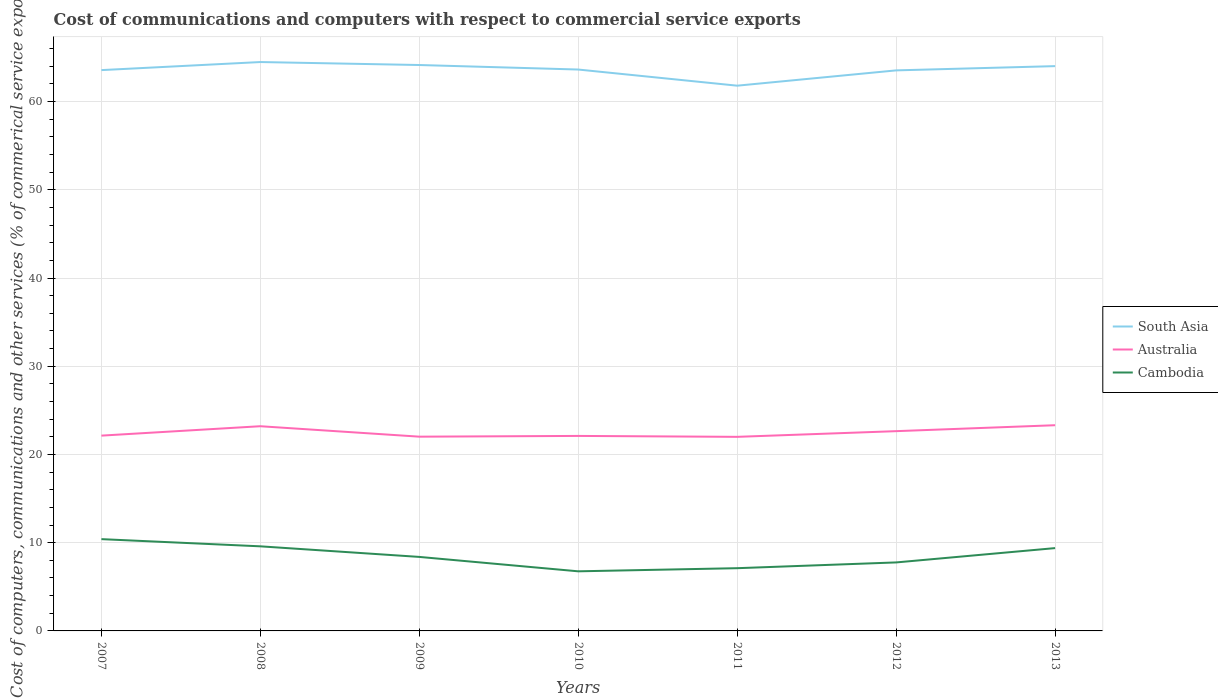How many different coloured lines are there?
Offer a very short reply. 3. Does the line corresponding to Australia intersect with the line corresponding to South Asia?
Offer a terse response. No. Is the number of lines equal to the number of legend labels?
Offer a very short reply. Yes. Across all years, what is the maximum cost of communications and computers in Australia?
Provide a short and direct response. 22. What is the total cost of communications and computers in South Asia in the graph?
Offer a very short reply. 0.95. What is the difference between the highest and the second highest cost of communications and computers in South Asia?
Give a very brief answer. 2.68. What is the difference between the highest and the lowest cost of communications and computers in Australia?
Ensure brevity in your answer.  3. Is the cost of communications and computers in Cambodia strictly greater than the cost of communications and computers in Australia over the years?
Your response must be concise. Yes. How many years are there in the graph?
Provide a succinct answer. 7. Are the values on the major ticks of Y-axis written in scientific E-notation?
Provide a short and direct response. No. How many legend labels are there?
Provide a succinct answer. 3. What is the title of the graph?
Make the answer very short. Cost of communications and computers with respect to commercial service exports. What is the label or title of the Y-axis?
Provide a succinct answer. Cost of computers, communications and other services (% of commerical service exports). What is the Cost of computers, communications and other services (% of commerical service exports) of South Asia in 2007?
Your answer should be very brief. 63.57. What is the Cost of computers, communications and other services (% of commerical service exports) of Australia in 2007?
Make the answer very short. 22.14. What is the Cost of computers, communications and other services (% of commerical service exports) in Cambodia in 2007?
Ensure brevity in your answer.  10.4. What is the Cost of computers, communications and other services (% of commerical service exports) in South Asia in 2008?
Keep it short and to the point. 64.49. What is the Cost of computers, communications and other services (% of commerical service exports) in Australia in 2008?
Your response must be concise. 23.2. What is the Cost of computers, communications and other services (% of commerical service exports) in Cambodia in 2008?
Your answer should be very brief. 9.59. What is the Cost of computers, communications and other services (% of commerical service exports) in South Asia in 2009?
Your answer should be very brief. 64.15. What is the Cost of computers, communications and other services (% of commerical service exports) of Australia in 2009?
Ensure brevity in your answer.  22.02. What is the Cost of computers, communications and other services (% of commerical service exports) of Cambodia in 2009?
Your response must be concise. 8.39. What is the Cost of computers, communications and other services (% of commerical service exports) in South Asia in 2010?
Provide a short and direct response. 63.64. What is the Cost of computers, communications and other services (% of commerical service exports) of Australia in 2010?
Provide a short and direct response. 22.1. What is the Cost of computers, communications and other services (% of commerical service exports) of Cambodia in 2010?
Your answer should be very brief. 6.76. What is the Cost of computers, communications and other services (% of commerical service exports) of South Asia in 2011?
Your response must be concise. 61.81. What is the Cost of computers, communications and other services (% of commerical service exports) of Australia in 2011?
Offer a very short reply. 22. What is the Cost of computers, communications and other services (% of commerical service exports) in Cambodia in 2011?
Make the answer very short. 7.11. What is the Cost of computers, communications and other services (% of commerical service exports) in South Asia in 2012?
Your answer should be very brief. 63.54. What is the Cost of computers, communications and other services (% of commerical service exports) in Australia in 2012?
Offer a very short reply. 22.64. What is the Cost of computers, communications and other services (% of commerical service exports) of Cambodia in 2012?
Your answer should be compact. 7.76. What is the Cost of computers, communications and other services (% of commerical service exports) in South Asia in 2013?
Provide a succinct answer. 64.02. What is the Cost of computers, communications and other services (% of commerical service exports) in Australia in 2013?
Provide a short and direct response. 23.32. What is the Cost of computers, communications and other services (% of commerical service exports) of Cambodia in 2013?
Your answer should be compact. 9.39. Across all years, what is the maximum Cost of computers, communications and other services (% of commerical service exports) in South Asia?
Offer a very short reply. 64.49. Across all years, what is the maximum Cost of computers, communications and other services (% of commerical service exports) of Australia?
Your response must be concise. 23.32. Across all years, what is the maximum Cost of computers, communications and other services (% of commerical service exports) in Cambodia?
Keep it short and to the point. 10.4. Across all years, what is the minimum Cost of computers, communications and other services (% of commerical service exports) of South Asia?
Provide a succinct answer. 61.81. Across all years, what is the minimum Cost of computers, communications and other services (% of commerical service exports) in Australia?
Keep it short and to the point. 22. Across all years, what is the minimum Cost of computers, communications and other services (% of commerical service exports) of Cambodia?
Your response must be concise. 6.76. What is the total Cost of computers, communications and other services (% of commerical service exports) in South Asia in the graph?
Offer a very short reply. 445.21. What is the total Cost of computers, communications and other services (% of commerical service exports) in Australia in the graph?
Give a very brief answer. 157.42. What is the total Cost of computers, communications and other services (% of commerical service exports) in Cambodia in the graph?
Keep it short and to the point. 59.4. What is the difference between the Cost of computers, communications and other services (% of commerical service exports) of South Asia in 2007 and that in 2008?
Your answer should be very brief. -0.92. What is the difference between the Cost of computers, communications and other services (% of commerical service exports) in Australia in 2007 and that in 2008?
Your response must be concise. -1.07. What is the difference between the Cost of computers, communications and other services (% of commerical service exports) of Cambodia in 2007 and that in 2008?
Your answer should be compact. 0.81. What is the difference between the Cost of computers, communications and other services (% of commerical service exports) in South Asia in 2007 and that in 2009?
Ensure brevity in your answer.  -0.58. What is the difference between the Cost of computers, communications and other services (% of commerical service exports) in Australia in 2007 and that in 2009?
Ensure brevity in your answer.  0.12. What is the difference between the Cost of computers, communications and other services (% of commerical service exports) of Cambodia in 2007 and that in 2009?
Your answer should be compact. 2.01. What is the difference between the Cost of computers, communications and other services (% of commerical service exports) in South Asia in 2007 and that in 2010?
Keep it short and to the point. -0.07. What is the difference between the Cost of computers, communications and other services (% of commerical service exports) in Australia in 2007 and that in 2010?
Your answer should be very brief. 0.03. What is the difference between the Cost of computers, communications and other services (% of commerical service exports) of Cambodia in 2007 and that in 2010?
Your answer should be very brief. 3.65. What is the difference between the Cost of computers, communications and other services (% of commerical service exports) of South Asia in 2007 and that in 2011?
Ensure brevity in your answer.  1.76. What is the difference between the Cost of computers, communications and other services (% of commerical service exports) of Australia in 2007 and that in 2011?
Give a very brief answer. 0.14. What is the difference between the Cost of computers, communications and other services (% of commerical service exports) in Cambodia in 2007 and that in 2011?
Give a very brief answer. 3.29. What is the difference between the Cost of computers, communications and other services (% of commerical service exports) in South Asia in 2007 and that in 2012?
Your answer should be very brief. 0.03. What is the difference between the Cost of computers, communications and other services (% of commerical service exports) in Australia in 2007 and that in 2012?
Give a very brief answer. -0.51. What is the difference between the Cost of computers, communications and other services (% of commerical service exports) in Cambodia in 2007 and that in 2012?
Keep it short and to the point. 2.64. What is the difference between the Cost of computers, communications and other services (% of commerical service exports) of South Asia in 2007 and that in 2013?
Provide a succinct answer. -0.45. What is the difference between the Cost of computers, communications and other services (% of commerical service exports) in Australia in 2007 and that in 2013?
Your answer should be compact. -1.18. What is the difference between the Cost of computers, communications and other services (% of commerical service exports) in Cambodia in 2007 and that in 2013?
Keep it short and to the point. 1.01. What is the difference between the Cost of computers, communications and other services (% of commerical service exports) of South Asia in 2008 and that in 2009?
Make the answer very short. 0.34. What is the difference between the Cost of computers, communications and other services (% of commerical service exports) of Australia in 2008 and that in 2009?
Your answer should be very brief. 1.18. What is the difference between the Cost of computers, communications and other services (% of commerical service exports) of Cambodia in 2008 and that in 2009?
Offer a very short reply. 1.2. What is the difference between the Cost of computers, communications and other services (% of commerical service exports) of South Asia in 2008 and that in 2010?
Provide a short and direct response. 0.85. What is the difference between the Cost of computers, communications and other services (% of commerical service exports) in Australia in 2008 and that in 2010?
Offer a terse response. 1.1. What is the difference between the Cost of computers, communications and other services (% of commerical service exports) in Cambodia in 2008 and that in 2010?
Provide a succinct answer. 2.83. What is the difference between the Cost of computers, communications and other services (% of commerical service exports) in South Asia in 2008 and that in 2011?
Ensure brevity in your answer.  2.68. What is the difference between the Cost of computers, communications and other services (% of commerical service exports) in Australia in 2008 and that in 2011?
Offer a terse response. 1.2. What is the difference between the Cost of computers, communications and other services (% of commerical service exports) in Cambodia in 2008 and that in 2011?
Provide a succinct answer. 2.48. What is the difference between the Cost of computers, communications and other services (% of commerical service exports) of South Asia in 2008 and that in 2012?
Give a very brief answer. 0.95. What is the difference between the Cost of computers, communications and other services (% of commerical service exports) of Australia in 2008 and that in 2012?
Your answer should be compact. 0.56. What is the difference between the Cost of computers, communications and other services (% of commerical service exports) in Cambodia in 2008 and that in 2012?
Provide a succinct answer. 1.83. What is the difference between the Cost of computers, communications and other services (% of commerical service exports) of South Asia in 2008 and that in 2013?
Make the answer very short. 0.46. What is the difference between the Cost of computers, communications and other services (% of commerical service exports) of Australia in 2008 and that in 2013?
Offer a very short reply. -0.11. What is the difference between the Cost of computers, communications and other services (% of commerical service exports) in Cambodia in 2008 and that in 2013?
Keep it short and to the point. 0.2. What is the difference between the Cost of computers, communications and other services (% of commerical service exports) in South Asia in 2009 and that in 2010?
Provide a short and direct response. 0.51. What is the difference between the Cost of computers, communications and other services (% of commerical service exports) in Australia in 2009 and that in 2010?
Ensure brevity in your answer.  -0.08. What is the difference between the Cost of computers, communications and other services (% of commerical service exports) of Cambodia in 2009 and that in 2010?
Make the answer very short. 1.63. What is the difference between the Cost of computers, communications and other services (% of commerical service exports) of South Asia in 2009 and that in 2011?
Give a very brief answer. 2.34. What is the difference between the Cost of computers, communications and other services (% of commerical service exports) in Australia in 2009 and that in 2011?
Your response must be concise. 0.02. What is the difference between the Cost of computers, communications and other services (% of commerical service exports) in Cambodia in 2009 and that in 2011?
Offer a very short reply. 1.28. What is the difference between the Cost of computers, communications and other services (% of commerical service exports) of South Asia in 2009 and that in 2012?
Provide a succinct answer. 0.61. What is the difference between the Cost of computers, communications and other services (% of commerical service exports) of Australia in 2009 and that in 2012?
Offer a terse response. -0.62. What is the difference between the Cost of computers, communications and other services (% of commerical service exports) of Cambodia in 2009 and that in 2012?
Your answer should be compact. 0.62. What is the difference between the Cost of computers, communications and other services (% of commerical service exports) in South Asia in 2009 and that in 2013?
Make the answer very short. 0.13. What is the difference between the Cost of computers, communications and other services (% of commerical service exports) in Australia in 2009 and that in 2013?
Keep it short and to the point. -1.3. What is the difference between the Cost of computers, communications and other services (% of commerical service exports) in Cambodia in 2009 and that in 2013?
Give a very brief answer. -1. What is the difference between the Cost of computers, communications and other services (% of commerical service exports) in South Asia in 2010 and that in 2011?
Offer a very short reply. 1.83. What is the difference between the Cost of computers, communications and other services (% of commerical service exports) of Australia in 2010 and that in 2011?
Your answer should be compact. 0.1. What is the difference between the Cost of computers, communications and other services (% of commerical service exports) in Cambodia in 2010 and that in 2011?
Your answer should be compact. -0.35. What is the difference between the Cost of computers, communications and other services (% of commerical service exports) of South Asia in 2010 and that in 2012?
Your answer should be compact. 0.1. What is the difference between the Cost of computers, communications and other services (% of commerical service exports) of Australia in 2010 and that in 2012?
Your response must be concise. -0.54. What is the difference between the Cost of computers, communications and other services (% of commerical service exports) of Cambodia in 2010 and that in 2012?
Provide a succinct answer. -1.01. What is the difference between the Cost of computers, communications and other services (% of commerical service exports) in South Asia in 2010 and that in 2013?
Give a very brief answer. -0.39. What is the difference between the Cost of computers, communications and other services (% of commerical service exports) in Australia in 2010 and that in 2013?
Your answer should be compact. -1.21. What is the difference between the Cost of computers, communications and other services (% of commerical service exports) of Cambodia in 2010 and that in 2013?
Your response must be concise. -2.63. What is the difference between the Cost of computers, communications and other services (% of commerical service exports) of South Asia in 2011 and that in 2012?
Offer a terse response. -1.73. What is the difference between the Cost of computers, communications and other services (% of commerical service exports) in Australia in 2011 and that in 2012?
Make the answer very short. -0.64. What is the difference between the Cost of computers, communications and other services (% of commerical service exports) in Cambodia in 2011 and that in 2012?
Keep it short and to the point. -0.65. What is the difference between the Cost of computers, communications and other services (% of commerical service exports) in South Asia in 2011 and that in 2013?
Your answer should be compact. -2.22. What is the difference between the Cost of computers, communications and other services (% of commerical service exports) of Australia in 2011 and that in 2013?
Offer a very short reply. -1.32. What is the difference between the Cost of computers, communications and other services (% of commerical service exports) in Cambodia in 2011 and that in 2013?
Your response must be concise. -2.28. What is the difference between the Cost of computers, communications and other services (% of commerical service exports) in South Asia in 2012 and that in 2013?
Your response must be concise. -0.48. What is the difference between the Cost of computers, communications and other services (% of commerical service exports) in Australia in 2012 and that in 2013?
Your response must be concise. -0.67. What is the difference between the Cost of computers, communications and other services (% of commerical service exports) in Cambodia in 2012 and that in 2013?
Provide a succinct answer. -1.62. What is the difference between the Cost of computers, communications and other services (% of commerical service exports) in South Asia in 2007 and the Cost of computers, communications and other services (% of commerical service exports) in Australia in 2008?
Provide a short and direct response. 40.37. What is the difference between the Cost of computers, communications and other services (% of commerical service exports) of South Asia in 2007 and the Cost of computers, communications and other services (% of commerical service exports) of Cambodia in 2008?
Offer a very short reply. 53.98. What is the difference between the Cost of computers, communications and other services (% of commerical service exports) in Australia in 2007 and the Cost of computers, communications and other services (% of commerical service exports) in Cambodia in 2008?
Keep it short and to the point. 12.55. What is the difference between the Cost of computers, communications and other services (% of commerical service exports) of South Asia in 2007 and the Cost of computers, communications and other services (% of commerical service exports) of Australia in 2009?
Ensure brevity in your answer.  41.55. What is the difference between the Cost of computers, communications and other services (% of commerical service exports) of South Asia in 2007 and the Cost of computers, communications and other services (% of commerical service exports) of Cambodia in 2009?
Offer a terse response. 55.18. What is the difference between the Cost of computers, communications and other services (% of commerical service exports) of Australia in 2007 and the Cost of computers, communications and other services (% of commerical service exports) of Cambodia in 2009?
Provide a short and direct response. 13.75. What is the difference between the Cost of computers, communications and other services (% of commerical service exports) in South Asia in 2007 and the Cost of computers, communications and other services (% of commerical service exports) in Australia in 2010?
Provide a succinct answer. 41.47. What is the difference between the Cost of computers, communications and other services (% of commerical service exports) of South Asia in 2007 and the Cost of computers, communications and other services (% of commerical service exports) of Cambodia in 2010?
Your answer should be compact. 56.81. What is the difference between the Cost of computers, communications and other services (% of commerical service exports) in Australia in 2007 and the Cost of computers, communications and other services (% of commerical service exports) in Cambodia in 2010?
Your answer should be very brief. 15.38. What is the difference between the Cost of computers, communications and other services (% of commerical service exports) of South Asia in 2007 and the Cost of computers, communications and other services (% of commerical service exports) of Australia in 2011?
Your answer should be compact. 41.57. What is the difference between the Cost of computers, communications and other services (% of commerical service exports) in South Asia in 2007 and the Cost of computers, communications and other services (% of commerical service exports) in Cambodia in 2011?
Give a very brief answer. 56.46. What is the difference between the Cost of computers, communications and other services (% of commerical service exports) of Australia in 2007 and the Cost of computers, communications and other services (% of commerical service exports) of Cambodia in 2011?
Keep it short and to the point. 15.03. What is the difference between the Cost of computers, communications and other services (% of commerical service exports) of South Asia in 2007 and the Cost of computers, communications and other services (% of commerical service exports) of Australia in 2012?
Give a very brief answer. 40.93. What is the difference between the Cost of computers, communications and other services (% of commerical service exports) of South Asia in 2007 and the Cost of computers, communications and other services (% of commerical service exports) of Cambodia in 2012?
Provide a succinct answer. 55.81. What is the difference between the Cost of computers, communications and other services (% of commerical service exports) in Australia in 2007 and the Cost of computers, communications and other services (% of commerical service exports) in Cambodia in 2012?
Offer a terse response. 14.37. What is the difference between the Cost of computers, communications and other services (% of commerical service exports) in South Asia in 2007 and the Cost of computers, communications and other services (% of commerical service exports) in Australia in 2013?
Make the answer very short. 40.25. What is the difference between the Cost of computers, communications and other services (% of commerical service exports) in South Asia in 2007 and the Cost of computers, communications and other services (% of commerical service exports) in Cambodia in 2013?
Ensure brevity in your answer.  54.18. What is the difference between the Cost of computers, communications and other services (% of commerical service exports) of Australia in 2007 and the Cost of computers, communications and other services (% of commerical service exports) of Cambodia in 2013?
Provide a short and direct response. 12.75. What is the difference between the Cost of computers, communications and other services (% of commerical service exports) of South Asia in 2008 and the Cost of computers, communications and other services (% of commerical service exports) of Australia in 2009?
Ensure brevity in your answer.  42.47. What is the difference between the Cost of computers, communications and other services (% of commerical service exports) of South Asia in 2008 and the Cost of computers, communications and other services (% of commerical service exports) of Cambodia in 2009?
Offer a terse response. 56.1. What is the difference between the Cost of computers, communications and other services (% of commerical service exports) of Australia in 2008 and the Cost of computers, communications and other services (% of commerical service exports) of Cambodia in 2009?
Your answer should be compact. 14.81. What is the difference between the Cost of computers, communications and other services (% of commerical service exports) in South Asia in 2008 and the Cost of computers, communications and other services (% of commerical service exports) in Australia in 2010?
Offer a very short reply. 42.38. What is the difference between the Cost of computers, communications and other services (% of commerical service exports) of South Asia in 2008 and the Cost of computers, communications and other services (% of commerical service exports) of Cambodia in 2010?
Provide a succinct answer. 57.73. What is the difference between the Cost of computers, communications and other services (% of commerical service exports) in Australia in 2008 and the Cost of computers, communications and other services (% of commerical service exports) in Cambodia in 2010?
Your answer should be very brief. 16.45. What is the difference between the Cost of computers, communications and other services (% of commerical service exports) of South Asia in 2008 and the Cost of computers, communications and other services (% of commerical service exports) of Australia in 2011?
Offer a terse response. 42.49. What is the difference between the Cost of computers, communications and other services (% of commerical service exports) in South Asia in 2008 and the Cost of computers, communications and other services (% of commerical service exports) in Cambodia in 2011?
Offer a very short reply. 57.37. What is the difference between the Cost of computers, communications and other services (% of commerical service exports) of Australia in 2008 and the Cost of computers, communications and other services (% of commerical service exports) of Cambodia in 2011?
Your answer should be very brief. 16.09. What is the difference between the Cost of computers, communications and other services (% of commerical service exports) of South Asia in 2008 and the Cost of computers, communications and other services (% of commerical service exports) of Australia in 2012?
Provide a short and direct response. 41.84. What is the difference between the Cost of computers, communications and other services (% of commerical service exports) of South Asia in 2008 and the Cost of computers, communications and other services (% of commerical service exports) of Cambodia in 2012?
Make the answer very short. 56.72. What is the difference between the Cost of computers, communications and other services (% of commerical service exports) in Australia in 2008 and the Cost of computers, communications and other services (% of commerical service exports) in Cambodia in 2012?
Your answer should be very brief. 15.44. What is the difference between the Cost of computers, communications and other services (% of commerical service exports) in South Asia in 2008 and the Cost of computers, communications and other services (% of commerical service exports) in Australia in 2013?
Keep it short and to the point. 41.17. What is the difference between the Cost of computers, communications and other services (% of commerical service exports) of South Asia in 2008 and the Cost of computers, communications and other services (% of commerical service exports) of Cambodia in 2013?
Offer a terse response. 55.1. What is the difference between the Cost of computers, communications and other services (% of commerical service exports) in Australia in 2008 and the Cost of computers, communications and other services (% of commerical service exports) in Cambodia in 2013?
Provide a succinct answer. 13.82. What is the difference between the Cost of computers, communications and other services (% of commerical service exports) of South Asia in 2009 and the Cost of computers, communications and other services (% of commerical service exports) of Australia in 2010?
Provide a succinct answer. 42.04. What is the difference between the Cost of computers, communications and other services (% of commerical service exports) in South Asia in 2009 and the Cost of computers, communications and other services (% of commerical service exports) in Cambodia in 2010?
Make the answer very short. 57.39. What is the difference between the Cost of computers, communications and other services (% of commerical service exports) in Australia in 2009 and the Cost of computers, communications and other services (% of commerical service exports) in Cambodia in 2010?
Your response must be concise. 15.26. What is the difference between the Cost of computers, communications and other services (% of commerical service exports) in South Asia in 2009 and the Cost of computers, communications and other services (% of commerical service exports) in Australia in 2011?
Provide a short and direct response. 42.15. What is the difference between the Cost of computers, communications and other services (% of commerical service exports) of South Asia in 2009 and the Cost of computers, communications and other services (% of commerical service exports) of Cambodia in 2011?
Your answer should be compact. 57.04. What is the difference between the Cost of computers, communications and other services (% of commerical service exports) of Australia in 2009 and the Cost of computers, communications and other services (% of commerical service exports) of Cambodia in 2011?
Your response must be concise. 14.91. What is the difference between the Cost of computers, communications and other services (% of commerical service exports) of South Asia in 2009 and the Cost of computers, communications and other services (% of commerical service exports) of Australia in 2012?
Provide a short and direct response. 41.5. What is the difference between the Cost of computers, communications and other services (% of commerical service exports) in South Asia in 2009 and the Cost of computers, communications and other services (% of commerical service exports) in Cambodia in 2012?
Offer a very short reply. 56.38. What is the difference between the Cost of computers, communications and other services (% of commerical service exports) of Australia in 2009 and the Cost of computers, communications and other services (% of commerical service exports) of Cambodia in 2012?
Make the answer very short. 14.26. What is the difference between the Cost of computers, communications and other services (% of commerical service exports) of South Asia in 2009 and the Cost of computers, communications and other services (% of commerical service exports) of Australia in 2013?
Your answer should be very brief. 40.83. What is the difference between the Cost of computers, communications and other services (% of commerical service exports) of South Asia in 2009 and the Cost of computers, communications and other services (% of commerical service exports) of Cambodia in 2013?
Provide a short and direct response. 54.76. What is the difference between the Cost of computers, communications and other services (% of commerical service exports) in Australia in 2009 and the Cost of computers, communications and other services (% of commerical service exports) in Cambodia in 2013?
Offer a terse response. 12.63. What is the difference between the Cost of computers, communications and other services (% of commerical service exports) of South Asia in 2010 and the Cost of computers, communications and other services (% of commerical service exports) of Australia in 2011?
Give a very brief answer. 41.64. What is the difference between the Cost of computers, communications and other services (% of commerical service exports) of South Asia in 2010 and the Cost of computers, communications and other services (% of commerical service exports) of Cambodia in 2011?
Provide a short and direct response. 56.52. What is the difference between the Cost of computers, communications and other services (% of commerical service exports) in Australia in 2010 and the Cost of computers, communications and other services (% of commerical service exports) in Cambodia in 2011?
Give a very brief answer. 14.99. What is the difference between the Cost of computers, communications and other services (% of commerical service exports) in South Asia in 2010 and the Cost of computers, communications and other services (% of commerical service exports) in Australia in 2012?
Keep it short and to the point. 40.99. What is the difference between the Cost of computers, communications and other services (% of commerical service exports) of South Asia in 2010 and the Cost of computers, communications and other services (% of commerical service exports) of Cambodia in 2012?
Provide a succinct answer. 55.87. What is the difference between the Cost of computers, communications and other services (% of commerical service exports) of Australia in 2010 and the Cost of computers, communications and other services (% of commerical service exports) of Cambodia in 2012?
Provide a short and direct response. 14.34. What is the difference between the Cost of computers, communications and other services (% of commerical service exports) of South Asia in 2010 and the Cost of computers, communications and other services (% of commerical service exports) of Australia in 2013?
Your answer should be compact. 40.32. What is the difference between the Cost of computers, communications and other services (% of commerical service exports) in South Asia in 2010 and the Cost of computers, communications and other services (% of commerical service exports) in Cambodia in 2013?
Provide a short and direct response. 54.25. What is the difference between the Cost of computers, communications and other services (% of commerical service exports) of Australia in 2010 and the Cost of computers, communications and other services (% of commerical service exports) of Cambodia in 2013?
Ensure brevity in your answer.  12.72. What is the difference between the Cost of computers, communications and other services (% of commerical service exports) of South Asia in 2011 and the Cost of computers, communications and other services (% of commerical service exports) of Australia in 2012?
Your answer should be very brief. 39.16. What is the difference between the Cost of computers, communications and other services (% of commerical service exports) in South Asia in 2011 and the Cost of computers, communications and other services (% of commerical service exports) in Cambodia in 2012?
Your answer should be compact. 54.04. What is the difference between the Cost of computers, communications and other services (% of commerical service exports) in Australia in 2011 and the Cost of computers, communications and other services (% of commerical service exports) in Cambodia in 2012?
Offer a terse response. 14.24. What is the difference between the Cost of computers, communications and other services (% of commerical service exports) of South Asia in 2011 and the Cost of computers, communications and other services (% of commerical service exports) of Australia in 2013?
Make the answer very short. 38.49. What is the difference between the Cost of computers, communications and other services (% of commerical service exports) in South Asia in 2011 and the Cost of computers, communications and other services (% of commerical service exports) in Cambodia in 2013?
Provide a succinct answer. 52.42. What is the difference between the Cost of computers, communications and other services (% of commerical service exports) of Australia in 2011 and the Cost of computers, communications and other services (% of commerical service exports) of Cambodia in 2013?
Provide a short and direct response. 12.61. What is the difference between the Cost of computers, communications and other services (% of commerical service exports) in South Asia in 2012 and the Cost of computers, communications and other services (% of commerical service exports) in Australia in 2013?
Ensure brevity in your answer.  40.22. What is the difference between the Cost of computers, communications and other services (% of commerical service exports) in South Asia in 2012 and the Cost of computers, communications and other services (% of commerical service exports) in Cambodia in 2013?
Give a very brief answer. 54.15. What is the difference between the Cost of computers, communications and other services (% of commerical service exports) of Australia in 2012 and the Cost of computers, communications and other services (% of commerical service exports) of Cambodia in 2013?
Ensure brevity in your answer.  13.26. What is the average Cost of computers, communications and other services (% of commerical service exports) in South Asia per year?
Provide a succinct answer. 63.6. What is the average Cost of computers, communications and other services (% of commerical service exports) of Australia per year?
Provide a short and direct response. 22.49. What is the average Cost of computers, communications and other services (% of commerical service exports) of Cambodia per year?
Give a very brief answer. 8.49. In the year 2007, what is the difference between the Cost of computers, communications and other services (% of commerical service exports) in South Asia and Cost of computers, communications and other services (% of commerical service exports) in Australia?
Give a very brief answer. 41.43. In the year 2007, what is the difference between the Cost of computers, communications and other services (% of commerical service exports) of South Asia and Cost of computers, communications and other services (% of commerical service exports) of Cambodia?
Provide a short and direct response. 53.17. In the year 2007, what is the difference between the Cost of computers, communications and other services (% of commerical service exports) in Australia and Cost of computers, communications and other services (% of commerical service exports) in Cambodia?
Provide a succinct answer. 11.73. In the year 2008, what is the difference between the Cost of computers, communications and other services (% of commerical service exports) in South Asia and Cost of computers, communications and other services (% of commerical service exports) in Australia?
Your response must be concise. 41.28. In the year 2008, what is the difference between the Cost of computers, communications and other services (% of commerical service exports) of South Asia and Cost of computers, communications and other services (% of commerical service exports) of Cambodia?
Provide a succinct answer. 54.9. In the year 2008, what is the difference between the Cost of computers, communications and other services (% of commerical service exports) of Australia and Cost of computers, communications and other services (% of commerical service exports) of Cambodia?
Provide a succinct answer. 13.61. In the year 2009, what is the difference between the Cost of computers, communications and other services (% of commerical service exports) in South Asia and Cost of computers, communications and other services (% of commerical service exports) in Australia?
Make the answer very short. 42.13. In the year 2009, what is the difference between the Cost of computers, communications and other services (% of commerical service exports) of South Asia and Cost of computers, communications and other services (% of commerical service exports) of Cambodia?
Offer a very short reply. 55.76. In the year 2009, what is the difference between the Cost of computers, communications and other services (% of commerical service exports) of Australia and Cost of computers, communications and other services (% of commerical service exports) of Cambodia?
Your answer should be compact. 13.63. In the year 2010, what is the difference between the Cost of computers, communications and other services (% of commerical service exports) in South Asia and Cost of computers, communications and other services (% of commerical service exports) in Australia?
Ensure brevity in your answer.  41.53. In the year 2010, what is the difference between the Cost of computers, communications and other services (% of commerical service exports) of South Asia and Cost of computers, communications and other services (% of commerical service exports) of Cambodia?
Give a very brief answer. 56.88. In the year 2010, what is the difference between the Cost of computers, communications and other services (% of commerical service exports) of Australia and Cost of computers, communications and other services (% of commerical service exports) of Cambodia?
Your response must be concise. 15.35. In the year 2011, what is the difference between the Cost of computers, communications and other services (% of commerical service exports) in South Asia and Cost of computers, communications and other services (% of commerical service exports) in Australia?
Offer a terse response. 39.81. In the year 2011, what is the difference between the Cost of computers, communications and other services (% of commerical service exports) of South Asia and Cost of computers, communications and other services (% of commerical service exports) of Cambodia?
Offer a very short reply. 54.69. In the year 2011, what is the difference between the Cost of computers, communications and other services (% of commerical service exports) in Australia and Cost of computers, communications and other services (% of commerical service exports) in Cambodia?
Give a very brief answer. 14.89. In the year 2012, what is the difference between the Cost of computers, communications and other services (% of commerical service exports) of South Asia and Cost of computers, communications and other services (% of commerical service exports) of Australia?
Your answer should be compact. 40.9. In the year 2012, what is the difference between the Cost of computers, communications and other services (% of commerical service exports) of South Asia and Cost of computers, communications and other services (% of commerical service exports) of Cambodia?
Provide a succinct answer. 55.78. In the year 2012, what is the difference between the Cost of computers, communications and other services (% of commerical service exports) in Australia and Cost of computers, communications and other services (% of commerical service exports) in Cambodia?
Provide a succinct answer. 14.88. In the year 2013, what is the difference between the Cost of computers, communications and other services (% of commerical service exports) of South Asia and Cost of computers, communications and other services (% of commerical service exports) of Australia?
Your response must be concise. 40.71. In the year 2013, what is the difference between the Cost of computers, communications and other services (% of commerical service exports) in South Asia and Cost of computers, communications and other services (% of commerical service exports) in Cambodia?
Ensure brevity in your answer.  54.63. In the year 2013, what is the difference between the Cost of computers, communications and other services (% of commerical service exports) in Australia and Cost of computers, communications and other services (% of commerical service exports) in Cambodia?
Keep it short and to the point. 13.93. What is the ratio of the Cost of computers, communications and other services (% of commerical service exports) in South Asia in 2007 to that in 2008?
Offer a very short reply. 0.99. What is the ratio of the Cost of computers, communications and other services (% of commerical service exports) in Australia in 2007 to that in 2008?
Offer a terse response. 0.95. What is the ratio of the Cost of computers, communications and other services (% of commerical service exports) in Cambodia in 2007 to that in 2008?
Your answer should be very brief. 1.08. What is the ratio of the Cost of computers, communications and other services (% of commerical service exports) in Australia in 2007 to that in 2009?
Provide a short and direct response. 1.01. What is the ratio of the Cost of computers, communications and other services (% of commerical service exports) of Cambodia in 2007 to that in 2009?
Make the answer very short. 1.24. What is the ratio of the Cost of computers, communications and other services (% of commerical service exports) in Australia in 2007 to that in 2010?
Your answer should be very brief. 1. What is the ratio of the Cost of computers, communications and other services (% of commerical service exports) in Cambodia in 2007 to that in 2010?
Your answer should be very brief. 1.54. What is the ratio of the Cost of computers, communications and other services (% of commerical service exports) of South Asia in 2007 to that in 2011?
Your response must be concise. 1.03. What is the ratio of the Cost of computers, communications and other services (% of commerical service exports) of Cambodia in 2007 to that in 2011?
Offer a terse response. 1.46. What is the ratio of the Cost of computers, communications and other services (% of commerical service exports) in South Asia in 2007 to that in 2012?
Keep it short and to the point. 1. What is the ratio of the Cost of computers, communications and other services (% of commerical service exports) of Australia in 2007 to that in 2012?
Offer a terse response. 0.98. What is the ratio of the Cost of computers, communications and other services (% of commerical service exports) in Cambodia in 2007 to that in 2012?
Offer a terse response. 1.34. What is the ratio of the Cost of computers, communications and other services (% of commerical service exports) in Australia in 2007 to that in 2013?
Give a very brief answer. 0.95. What is the ratio of the Cost of computers, communications and other services (% of commerical service exports) in Cambodia in 2007 to that in 2013?
Your answer should be compact. 1.11. What is the ratio of the Cost of computers, communications and other services (% of commerical service exports) in Australia in 2008 to that in 2009?
Ensure brevity in your answer.  1.05. What is the ratio of the Cost of computers, communications and other services (% of commerical service exports) of Cambodia in 2008 to that in 2009?
Provide a succinct answer. 1.14. What is the ratio of the Cost of computers, communications and other services (% of commerical service exports) in South Asia in 2008 to that in 2010?
Give a very brief answer. 1.01. What is the ratio of the Cost of computers, communications and other services (% of commerical service exports) in Australia in 2008 to that in 2010?
Ensure brevity in your answer.  1.05. What is the ratio of the Cost of computers, communications and other services (% of commerical service exports) of Cambodia in 2008 to that in 2010?
Offer a terse response. 1.42. What is the ratio of the Cost of computers, communications and other services (% of commerical service exports) in South Asia in 2008 to that in 2011?
Keep it short and to the point. 1.04. What is the ratio of the Cost of computers, communications and other services (% of commerical service exports) in Australia in 2008 to that in 2011?
Keep it short and to the point. 1.05. What is the ratio of the Cost of computers, communications and other services (% of commerical service exports) of Cambodia in 2008 to that in 2011?
Provide a succinct answer. 1.35. What is the ratio of the Cost of computers, communications and other services (% of commerical service exports) of South Asia in 2008 to that in 2012?
Ensure brevity in your answer.  1.01. What is the ratio of the Cost of computers, communications and other services (% of commerical service exports) of Australia in 2008 to that in 2012?
Make the answer very short. 1.02. What is the ratio of the Cost of computers, communications and other services (% of commerical service exports) in Cambodia in 2008 to that in 2012?
Provide a short and direct response. 1.24. What is the ratio of the Cost of computers, communications and other services (% of commerical service exports) in South Asia in 2008 to that in 2013?
Your answer should be very brief. 1.01. What is the ratio of the Cost of computers, communications and other services (% of commerical service exports) of Cambodia in 2008 to that in 2013?
Make the answer very short. 1.02. What is the ratio of the Cost of computers, communications and other services (% of commerical service exports) of Cambodia in 2009 to that in 2010?
Your answer should be compact. 1.24. What is the ratio of the Cost of computers, communications and other services (% of commerical service exports) of South Asia in 2009 to that in 2011?
Keep it short and to the point. 1.04. What is the ratio of the Cost of computers, communications and other services (% of commerical service exports) of Cambodia in 2009 to that in 2011?
Make the answer very short. 1.18. What is the ratio of the Cost of computers, communications and other services (% of commerical service exports) in South Asia in 2009 to that in 2012?
Keep it short and to the point. 1.01. What is the ratio of the Cost of computers, communications and other services (% of commerical service exports) of Australia in 2009 to that in 2012?
Offer a terse response. 0.97. What is the ratio of the Cost of computers, communications and other services (% of commerical service exports) in Cambodia in 2009 to that in 2012?
Offer a terse response. 1.08. What is the ratio of the Cost of computers, communications and other services (% of commerical service exports) of Australia in 2009 to that in 2013?
Give a very brief answer. 0.94. What is the ratio of the Cost of computers, communications and other services (% of commerical service exports) in Cambodia in 2009 to that in 2013?
Provide a succinct answer. 0.89. What is the ratio of the Cost of computers, communications and other services (% of commerical service exports) of South Asia in 2010 to that in 2011?
Your response must be concise. 1.03. What is the ratio of the Cost of computers, communications and other services (% of commerical service exports) in Cambodia in 2010 to that in 2011?
Your answer should be very brief. 0.95. What is the ratio of the Cost of computers, communications and other services (% of commerical service exports) of South Asia in 2010 to that in 2012?
Your answer should be compact. 1. What is the ratio of the Cost of computers, communications and other services (% of commerical service exports) of Australia in 2010 to that in 2012?
Offer a very short reply. 0.98. What is the ratio of the Cost of computers, communications and other services (% of commerical service exports) in Cambodia in 2010 to that in 2012?
Keep it short and to the point. 0.87. What is the ratio of the Cost of computers, communications and other services (% of commerical service exports) of South Asia in 2010 to that in 2013?
Your answer should be compact. 0.99. What is the ratio of the Cost of computers, communications and other services (% of commerical service exports) in Australia in 2010 to that in 2013?
Your answer should be very brief. 0.95. What is the ratio of the Cost of computers, communications and other services (% of commerical service exports) of Cambodia in 2010 to that in 2013?
Provide a succinct answer. 0.72. What is the ratio of the Cost of computers, communications and other services (% of commerical service exports) in South Asia in 2011 to that in 2012?
Provide a short and direct response. 0.97. What is the ratio of the Cost of computers, communications and other services (% of commerical service exports) in Australia in 2011 to that in 2012?
Your answer should be very brief. 0.97. What is the ratio of the Cost of computers, communications and other services (% of commerical service exports) of Cambodia in 2011 to that in 2012?
Offer a terse response. 0.92. What is the ratio of the Cost of computers, communications and other services (% of commerical service exports) of South Asia in 2011 to that in 2013?
Give a very brief answer. 0.97. What is the ratio of the Cost of computers, communications and other services (% of commerical service exports) in Australia in 2011 to that in 2013?
Keep it short and to the point. 0.94. What is the ratio of the Cost of computers, communications and other services (% of commerical service exports) of Cambodia in 2011 to that in 2013?
Provide a succinct answer. 0.76. What is the ratio of the Cost of computers, communications and other services (% of commerical service exports) of South Asia in 2012 to that in 2013?
Your response must be concise. 0.99. What is the ratio of the Cost of computers, communications and other services (% of commerical service exports) in Australia in 2012 to that in 2013?
Your answer should be compact. 0.97. What is the ratio of the Cost of computers, communications and other services (% of commerical service exports) of Cambodia in 2012 to that in 2013?
Ensure brevity in your answer.  0.83. What is the difference between the highest and the second highest Cost of computers, communications and other services (% of commerical service exports) of South Asia?
Provide a succinct answer. 0.34. What is the difference between the highest and the second highest Cost of computers, communications and other services (% of commerical service exports) in Australia?
Your response must be concise. 0.11. What is the difference between the highest and the second highest Cost of computers, communications and other services (% of commerical service exports) in Cambodia?
Offer a very short reply. 0.81. What is the difference between the highest and the lowest Cost of computers, communications and other services (% of commerical service exports) in South Asia?
Your answer should be very brief. 2.68. What is the difference between the highest and the lowest Cost of computers, communications and other services (% of commerical service exports) in Australia?
Offer a very short reply. 1.32. What is the difference between the highest and the lowest Cost of computers, communications and other services (% of commerical service exports) of Cambodia?
Your answer should be compact. 3.65. 